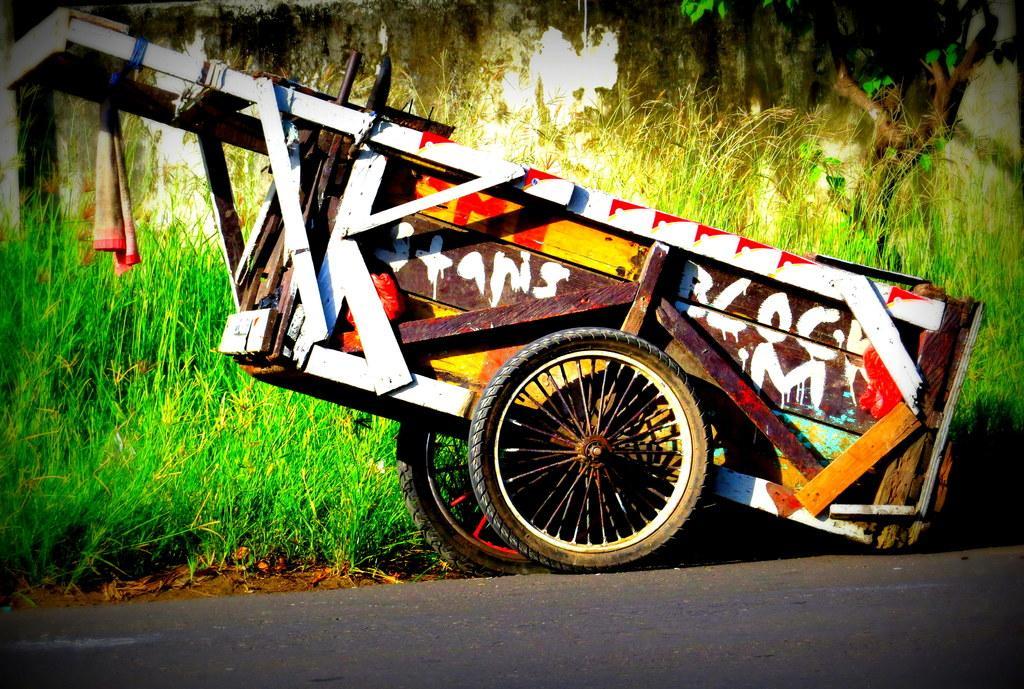Can you describe this image briefly? In this image in the center there is one vehicle, on the vehicle there is painting and text. At the bottom there is road, and in the background there are some trees and grass. 